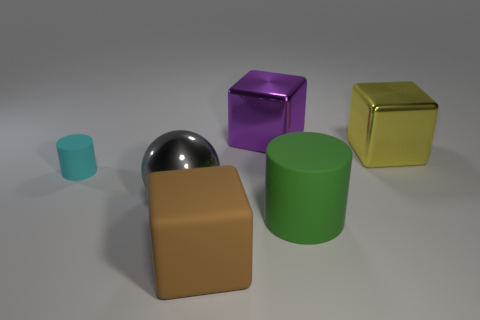Does the large cube behind the yellow metal thing have the same material as the brown block?
Your answer should be compact. No. What number of small blue cylinders have the same material as the big yellow object?
Ensure brevity in your answer.  0. Is the number of small cyan things right of the green rubber cylinder greater than the number of big objects?
Give a very brief answer. No. Is there another big thing of the same shape as the yellow object?
Your answer should be compact. Yes. What number of things are cyan matte things or spheres?
Ensure brevity in your answer.  2. There is a large yellow thing that is in front of the big purple metallic thing behind the brown rubber block; how many big shiny cubes are left of it?
Keep it short and to the point. 1. There is a big object that is the same shape as the small object; what is it made of?
Give a very brief answer. Rubber. What material is the cube that is both in front of the large purple metallic object and on the left side of the green rubber thing?
Your answer should be compact. Rubber. Is the number of large brown matte cubes left of the large shiny ball less than the number of rubber blocks on the left side of the cyan rubber object?
Make the answer very short. No. What number of other objects are the same size as the brown rubber cube?
Ensure brevity in your answer.  4. 